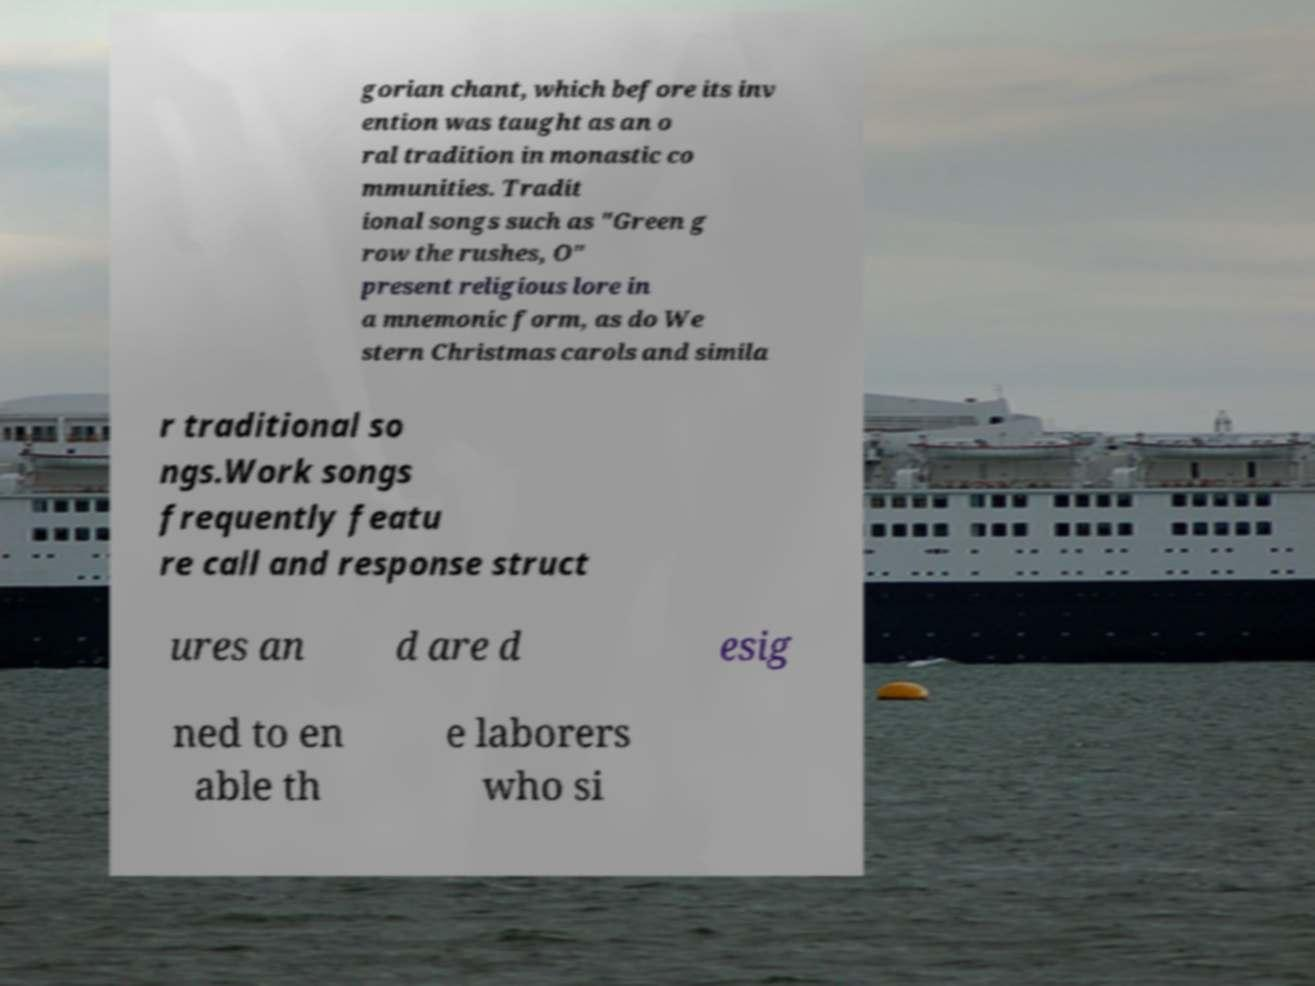Please identify and transcribe the text found in this image. gorian chant, which before its inv ention was taught as an o ral tradition in monastic co mmunities. Tradit ional songs such as "Green g row the rushes, O" present religious lore in a mnemonic form, as do We stern Christmas carols and simila r traditional so ngs.Work songs frequently featu re call and response struct ures an d are d esig ned to en able th e laborers who si 